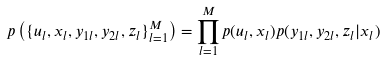Convert formula to latex. <formula><loc_0><loc_0><loc_500><loc_500>p \left ( \{ u _ { l } , x _ { l } , y _ { 1 l } , y _ { 2 l } , z _ { l } \} _ { l = 1 } ^ { M } \right ) = \prod _ { l = 1 } ^ { M } p ( u _ { l } , x _ { l } ) p ( y _ { 1 l } , y _ { 2 l } , z _ { l } | x _ { l } )</formula> 